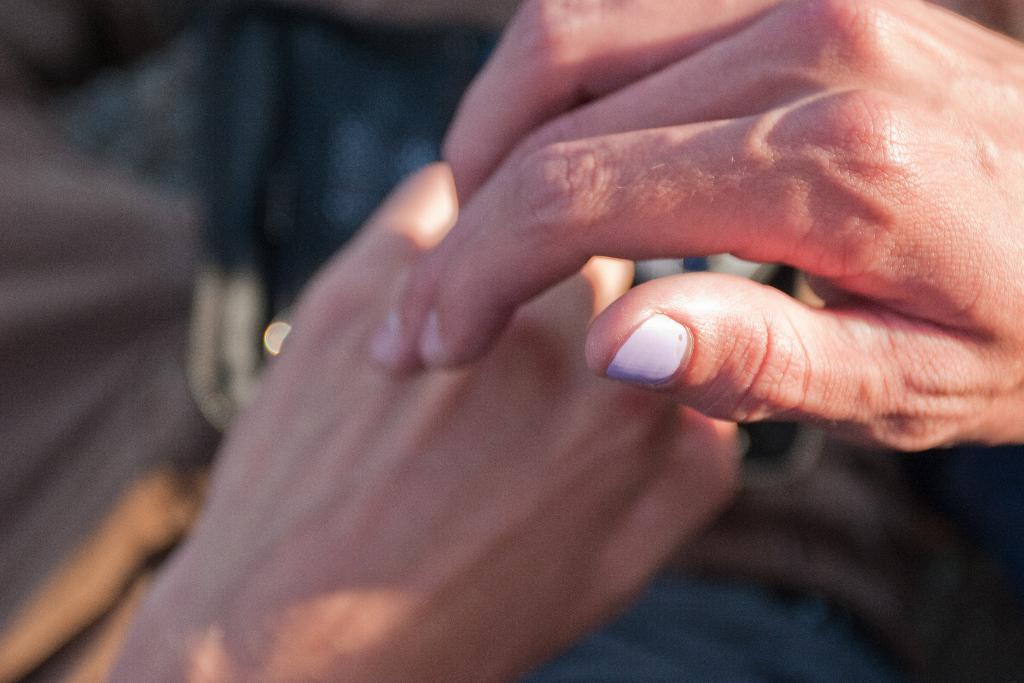What can be seen in the image? There are hands visible in the image. Can you describe the background of the image? The background of the image is blurred. How many ducks are present in the image? There are no ducks present in the image. What type of houses can be seen in the background of the image? There is no background or houses visible in the image, as the background is blurred and only hands are present. 